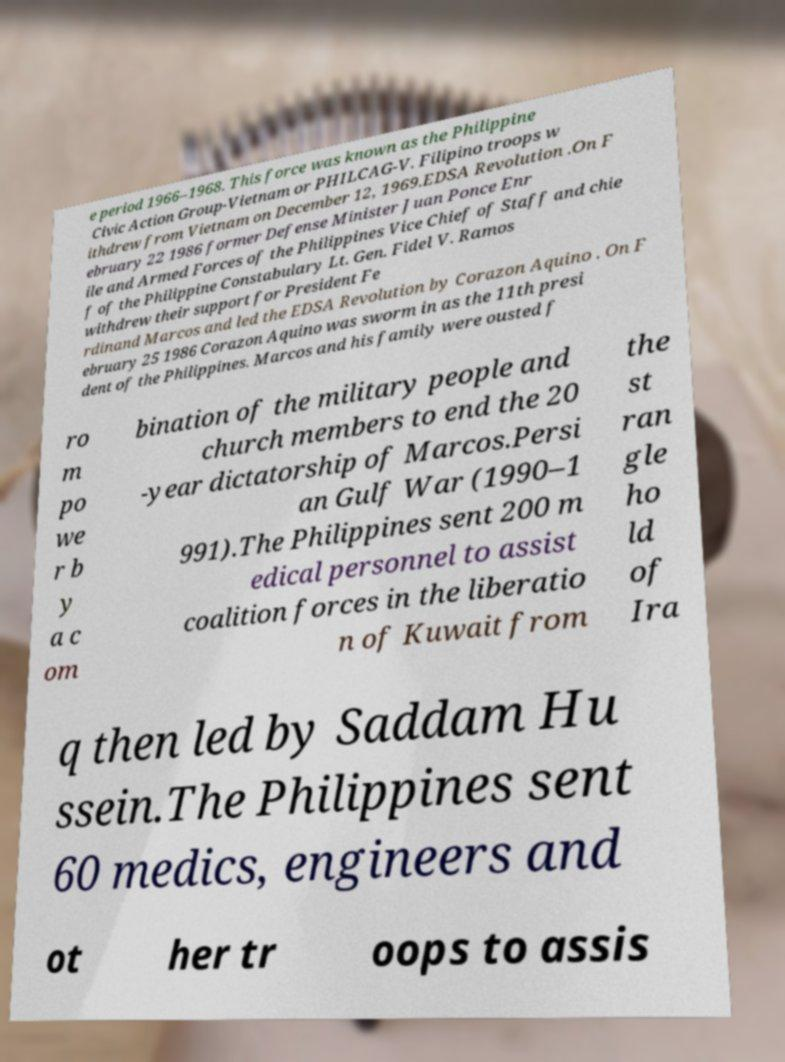I need the written content from this picture converted into text. Can you do that? e period 1966–1968. This force was known as the Philippine Civic Action Group-Vietnam or PHILCAG-V. Filipino troops w ithdrew from Vietnam on December 12, 1969.EDSA Revolution .On F ebruary 22 1986 former Defense Minister Juan Ponce Enr ile and Armed Forces of the Philippines Vice Chief of Staff and chie f of the Philippine Constabulary Lt. Gen. Fidel V. Ramos withdrew their support for President Fe rdinand Marcos and led the EDSA Revolution by Corazon Aquino . On F ebruary 25 1986 Corazon Aquino was sworm in as the 11th presi dent of the Philippines. Marcos and his family were ousted f ro m po we r b y a c om bination of the military people and church members to end the 20 -year dictatorship of Marcos.Persi an Gulf War (1990–1 991).The Philippines sent 200 m edical personnel to assist coalition forces in the liberatio n of Kuwait from the st ran gle ho ld of Ira q then led by Saddam Hu ssein.The Philippines sent 60 medics, engineers and ot her tr oops to assis 